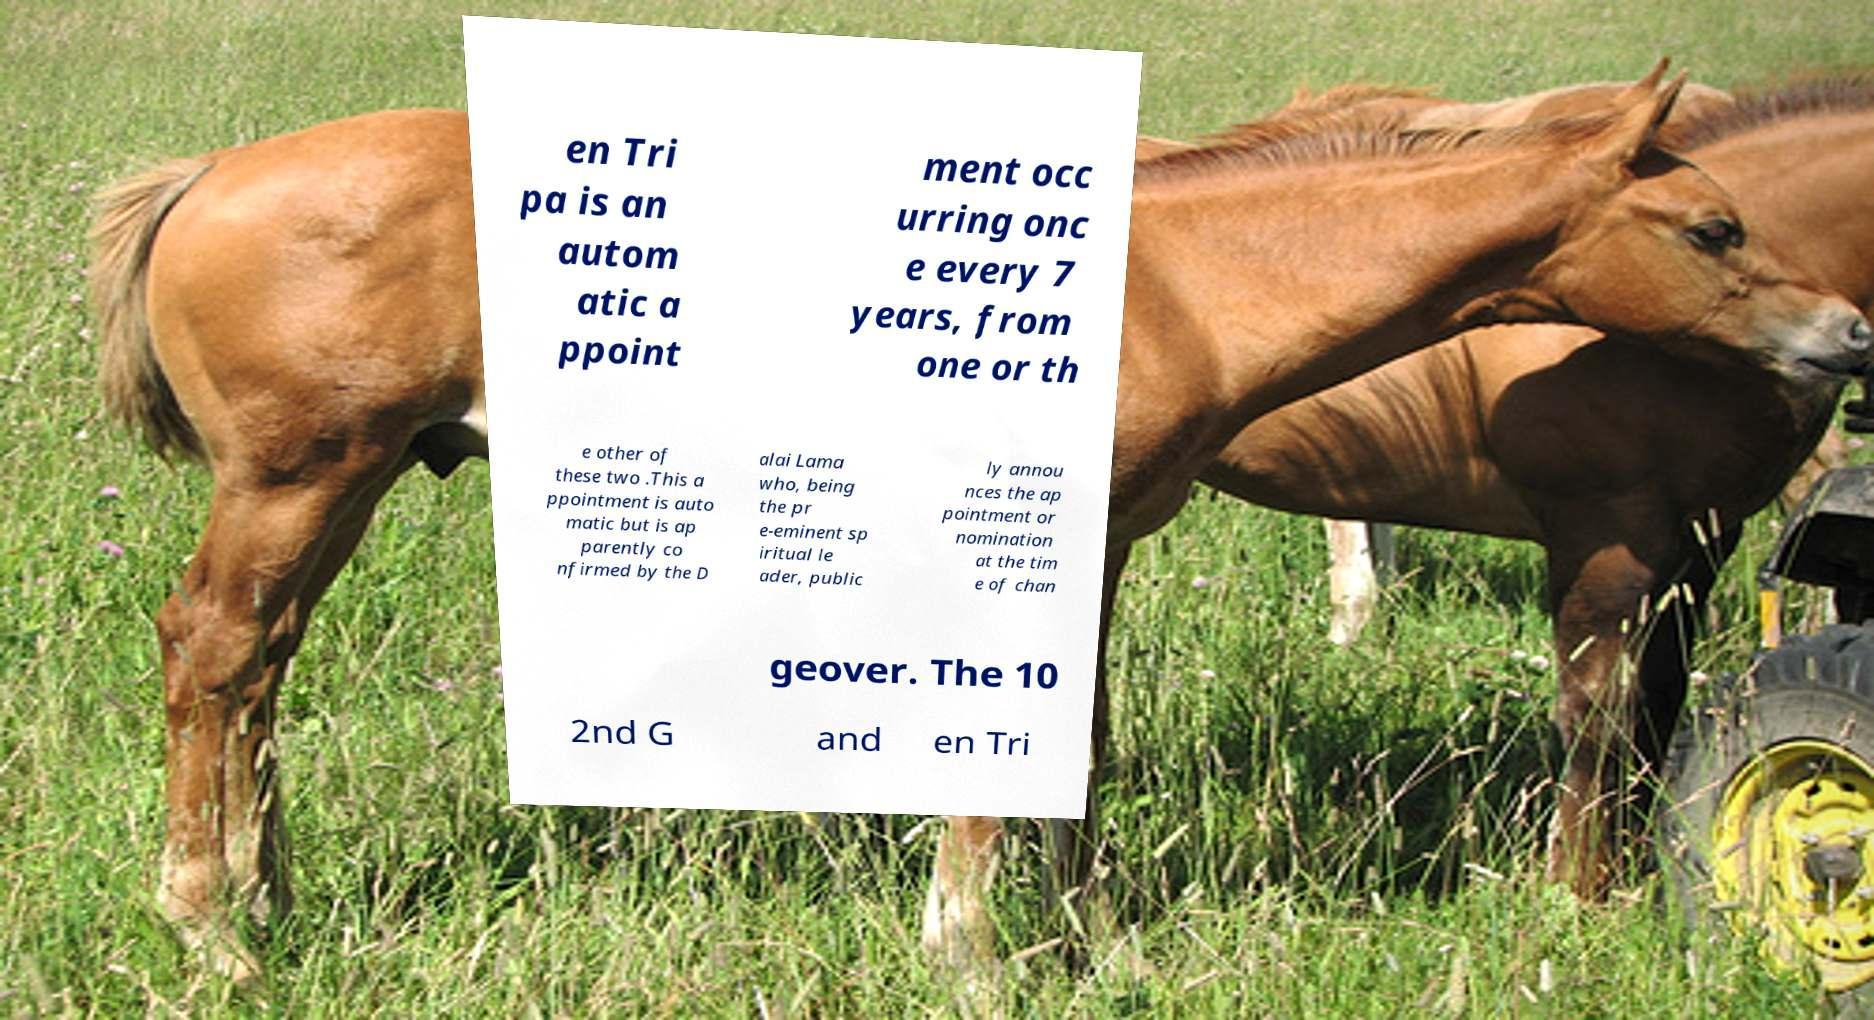There's text embedded in this image that I need extracted. Can you transcribe it verbatim? en Tri pa is an autom atic a ppoint ment occ urring onc e every 7 years, from one or th e other of these two .This a ppointment is auto matic but is ap parently co nfirmed by the D alai Lama who, being the pr e-eminent sp iritual le ader, public ly annou nces the ap pointment or nomination at the tim e of chan geover. The 10 2nd G and en Tri 